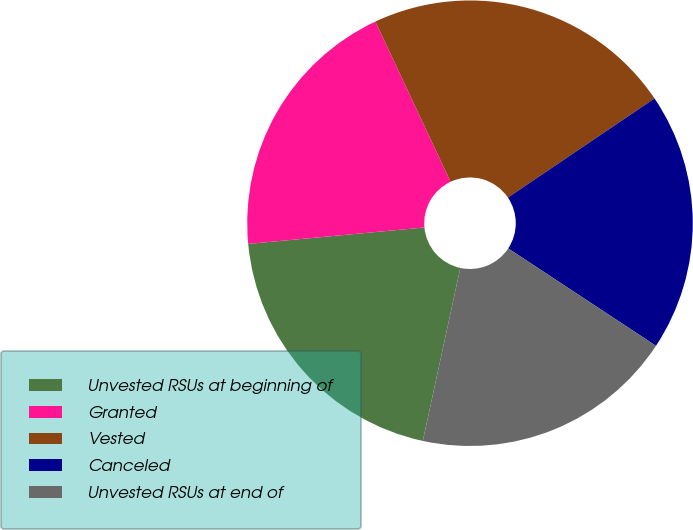<chart> <loc_0><loc_0><loc_500><loc_500><pie_chart><fcel>Unvested RSUs at beginning of<fcel>Granted<fcel>Vested<fcel>Canceled<fcel>Unvested RSUs at end of<nl><fcel>20.12%<fcel>19.5%<fcel>22.52%<fcel>18.74%<fcel>19.12%<nl></chart> 